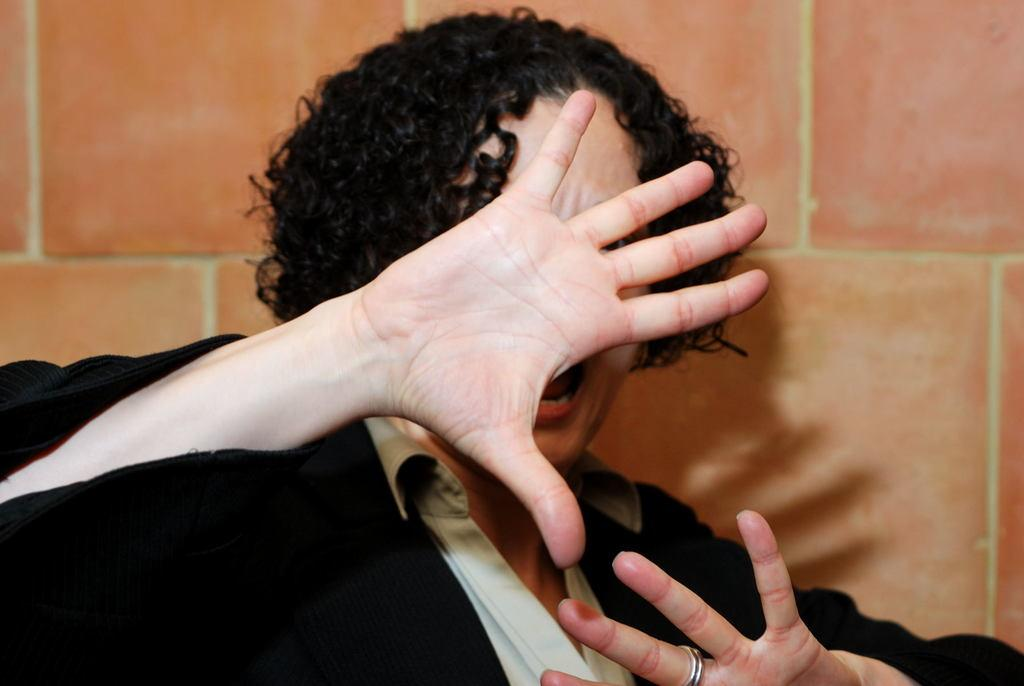Where was the image taken? The image was taken indoors. What can be seen in the background of the image? There is a wall in the background of the image. What is the main subject of the image? There is a person in the middle of the image. What type of thunder can be heard in the image? There is no sound in the image, so it is not possible to hear any thunder. 